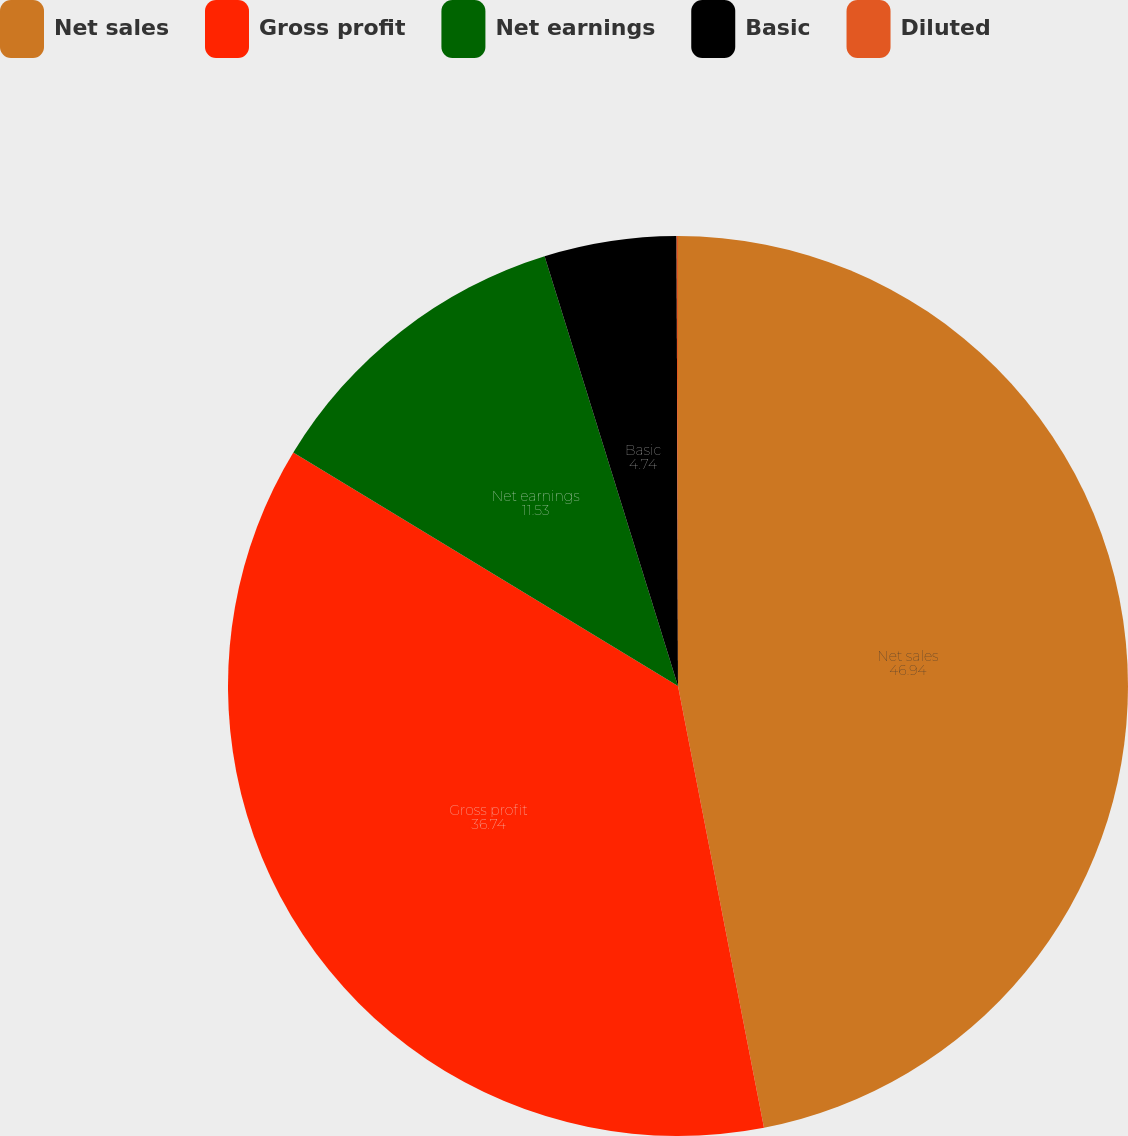Convert chart to OTSL. <chart><loc_0><loc_0><loc_500><loc_500><pie_chart><fcel>Net sales<fcel>Gross profit<fcel>Net earnings<fcel>Basic<fcel>Diluted<nl><fcel>46.94%<fcel>36.74%<fcel>11.53%<fcel>4.74%<fcel>0.05%<nl></chart> 